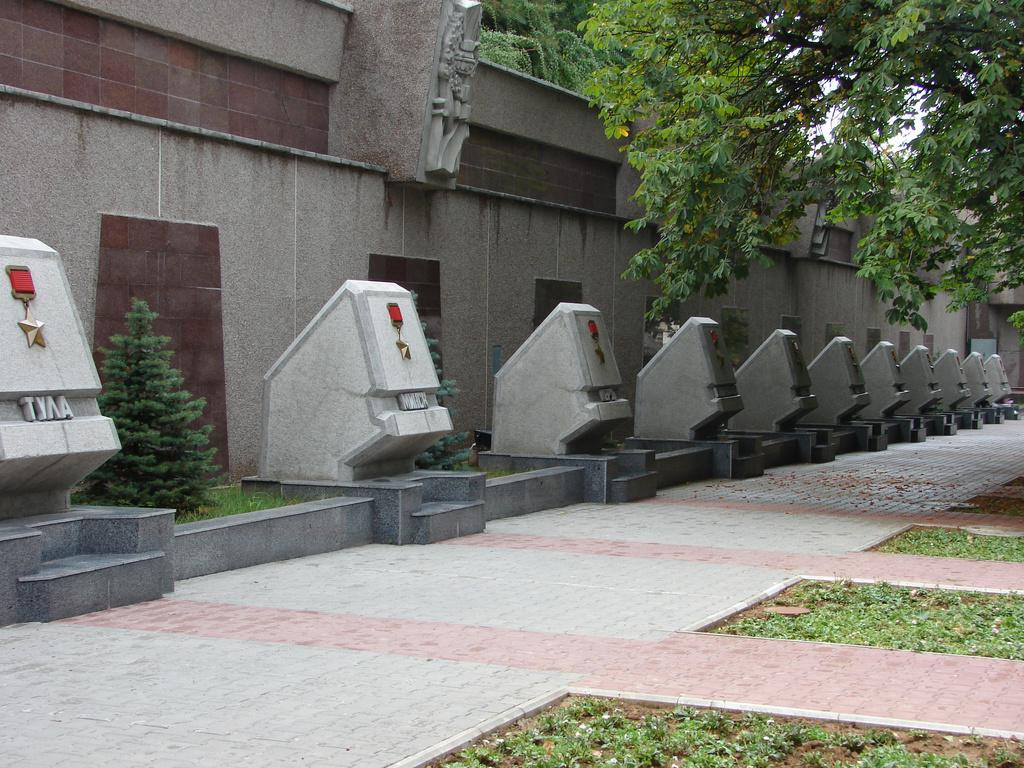What type of natural elements can be seen in the image? There are trees in the image. What type of inanimate objects can be seen in the image? There are stones in the image. What can be seen in the background of the image? There is a wall in the background of the image. What type of pleasure can be seen being experienced by the people at the airport in the image? There is no airport or people present in the image; it features trees, stones, and a wall. 